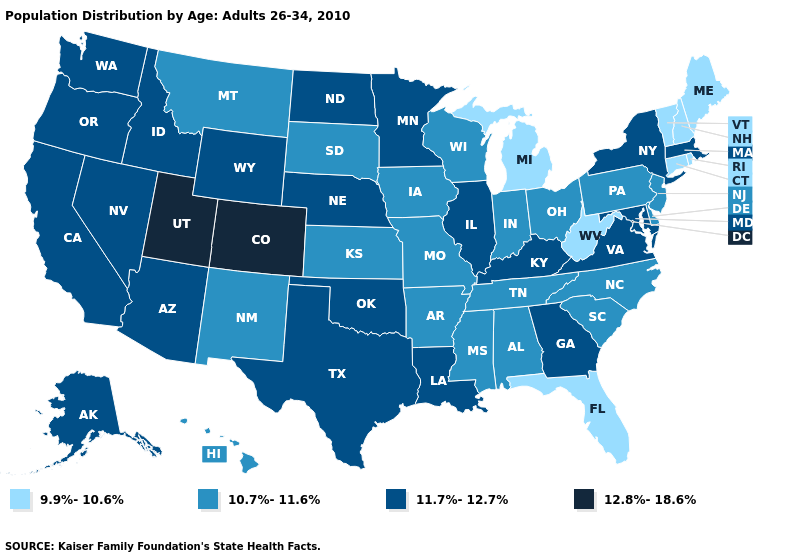Does the map have missing data?
Concise answer only. No. What is the lowest value in the USA?
Quick response, please. 9.9%-10.6%. Which states hav the highest value in the West?
Keep it brief. Colorado, Utah. Does Utah have a lower value than Maine?
Keep it brief. No. Does Florida have the highest value in the South?
Keep it brief. No. What is the value of New Hampshire?
Short answer required. 9.9%-10.6%. Among the states that border Alabama , does Georgia have the lowest value?
Keep it brief. No. Which states have the lowest value in the South?
Short answer required. Florida, West Virginia. What is the lowest value in states that border Delaware?
Concise answer only. 10.7%-11.6%. Name the states that have a value in the range 12.8%-18.6%?
Keep it brief. Colorado, Utah. Which states have the highest value in the USA?
Give a very brief answer. Colorado, Utah. What is the value of Kentucky?
Write a very short answer. 11.7%-12.7%. How many symbols are there in the legend?
Keep it brief. 4. Does Illinois have a higher value than Arkansas?
Short answer required. Yes. What is the value of New Mexico?
Be succinct. 10.7%-11.6%. 